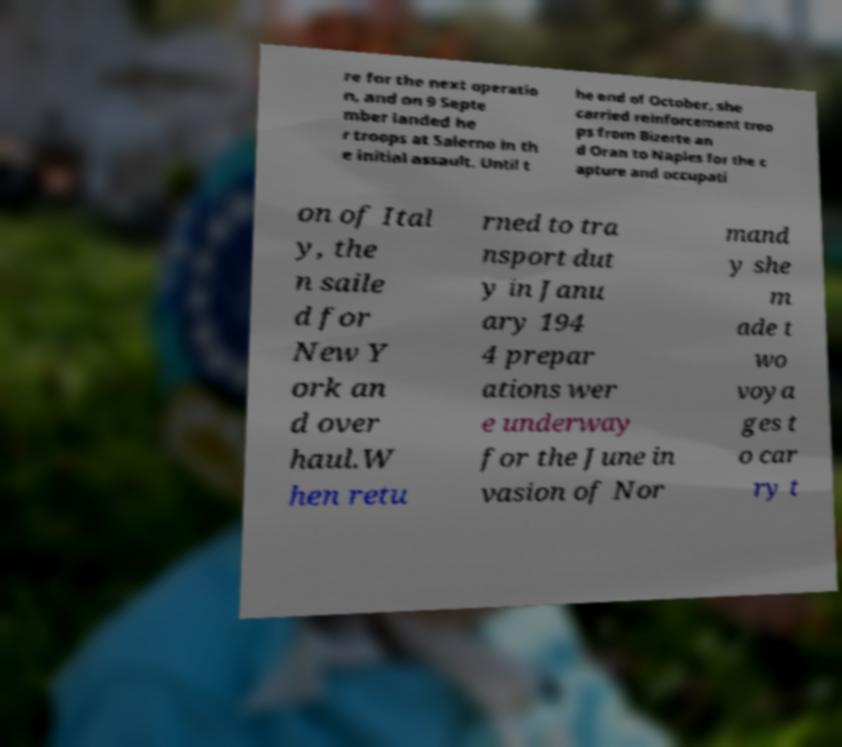I need the written content from this picture converted into text. Can you do that? re for the next operatio n, and on 9 Septe mber landed he r troops at Salerno in th e initial assault. Until t he end of October, she carried reinforcement troo ps from Bizerte an d Oran to Naples for the c apture and occupati on of Ital y, the n saile d for New Y ork an d over haul.W hen retu rned to tra nsport dut y in Janu ary 194 4 prepar ations wer e underway for the June in vasion of Nor mand y she m ade t wo voya ges t o car ry t 